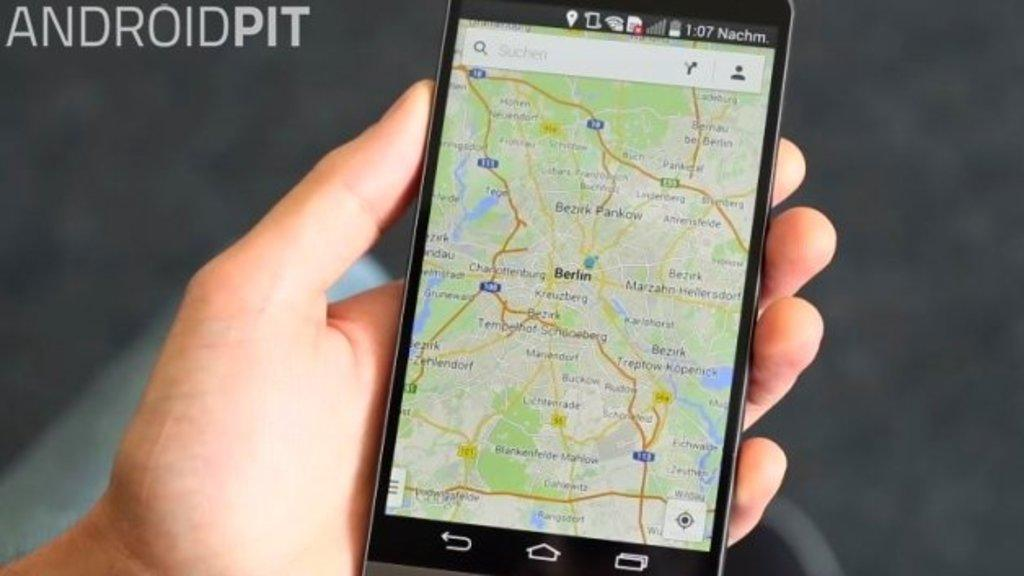<image>
Offer a succinct explanation of the picture presented. a phone with Berlin located on a map 